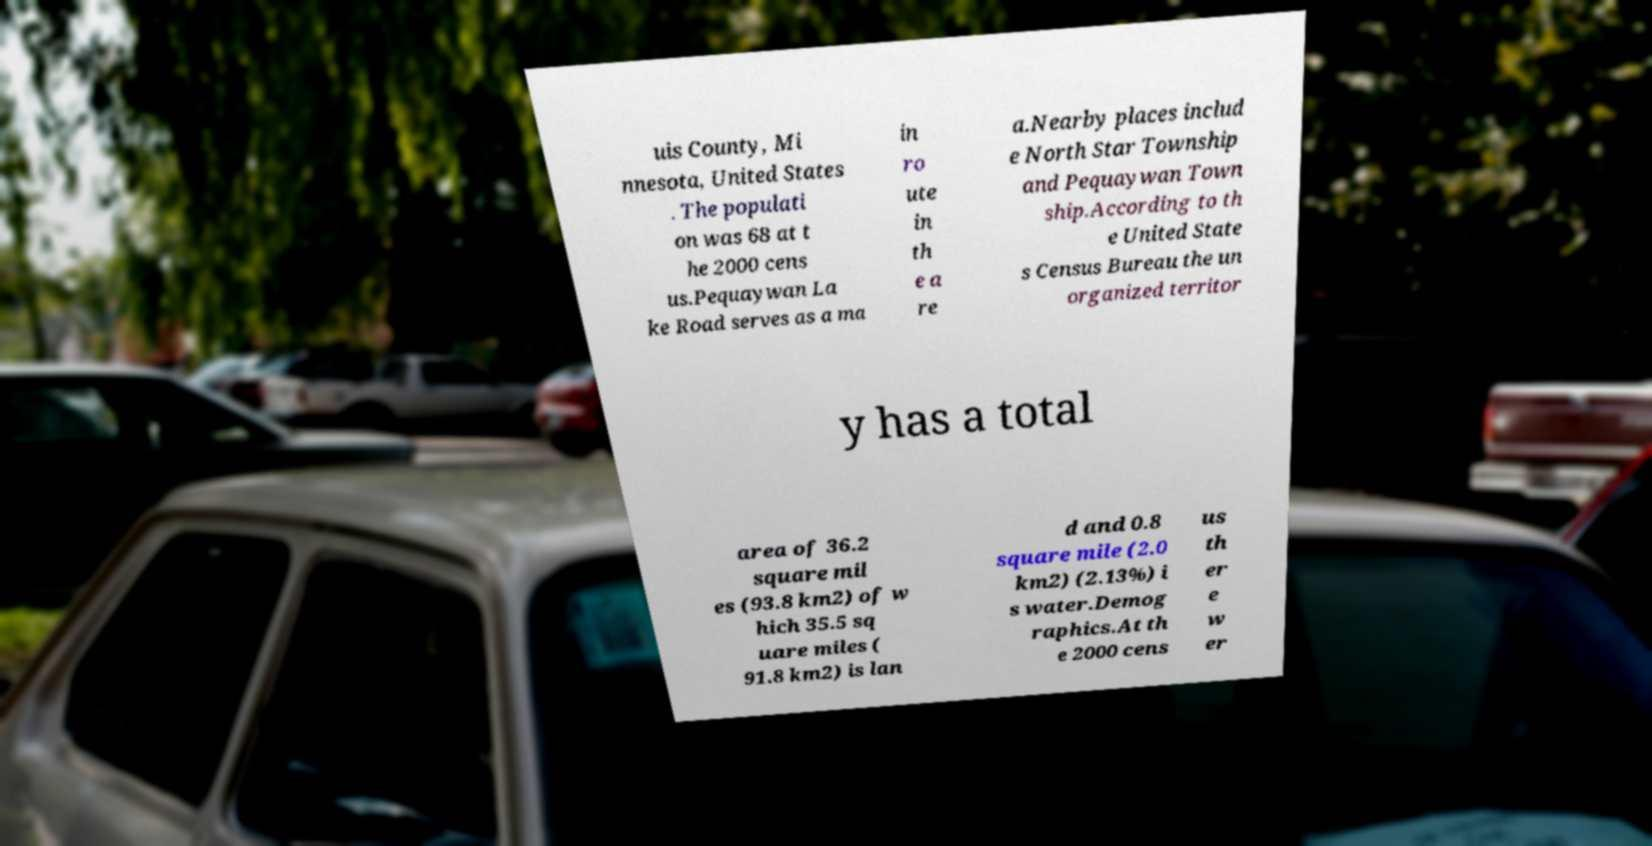What messages or text are displayed in this image? I need them in a readable, typed format. uis County, Mi nnesota, United States . The populati on was 68 at t he 2000 cens us.Pequaywan La ke Road serves as a ma in ro ute in th e a re a.Nearby places includ e North Star Township and Pequaywan Town ship.According to th e United State s Census Bureau the un organized territor y has a total area of 36.2 square mil es (93.8 km2) of w hich 35.5 sq uare miles ( 91.8 km2) is lan d and 0.8 square mile (2.0 km2) (2.13%) i s water.Demog raphics.At th e 2000 cens us th er e w er 